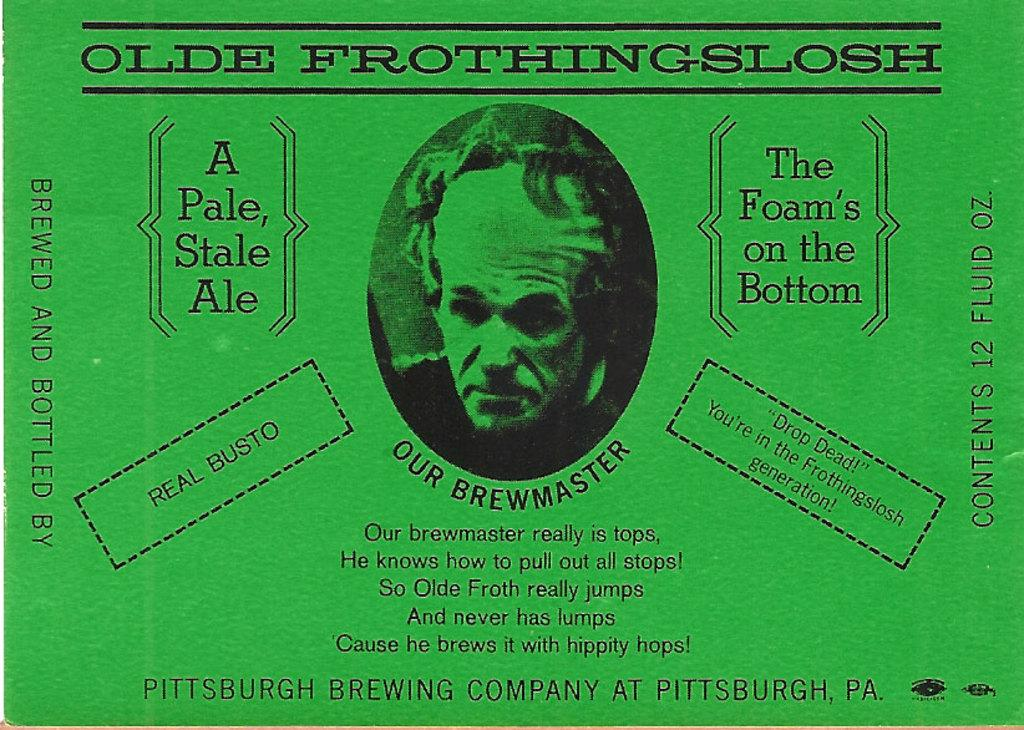What is the main subject of the image? The main subject of the image is a picture of a person. What else is present in the image besides the person? There is text written around the image. What color is the gold sidewalk in the image? There is no gold sidewalk present in the image; it only contains a picture of a person and text around it. 